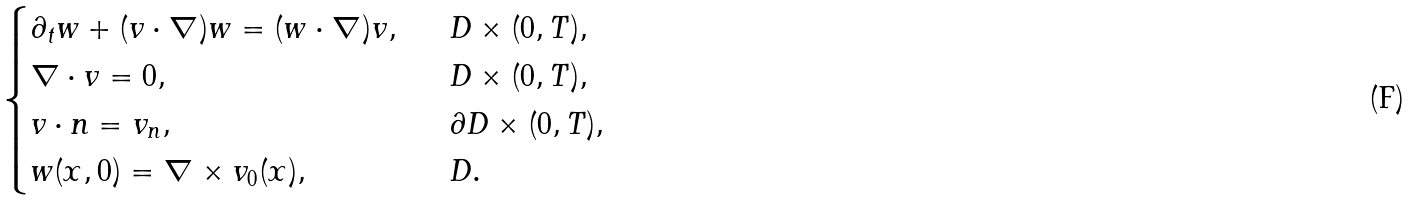Convert formula to latex. <formula><loc_0><loc_0><loc_500><loc_500>\begin{cases} \partial _ { t } w + ( v \cdot \nabla ) w = ( w \cdot \nabla ) v , \ \ & D \times ( 0 , T ) , \\ \nabla \cdot v = 0 , \ \ & D \times ( 0 , T ) , \\ v \cdot n = v _ { n } , \ \ & \partial D \times ( 0 , T ) , \\ w ( x , 0 ) = \nabla \times v _ { 0 } ( x ) , \ \ & D . \end{cases}</formula> 